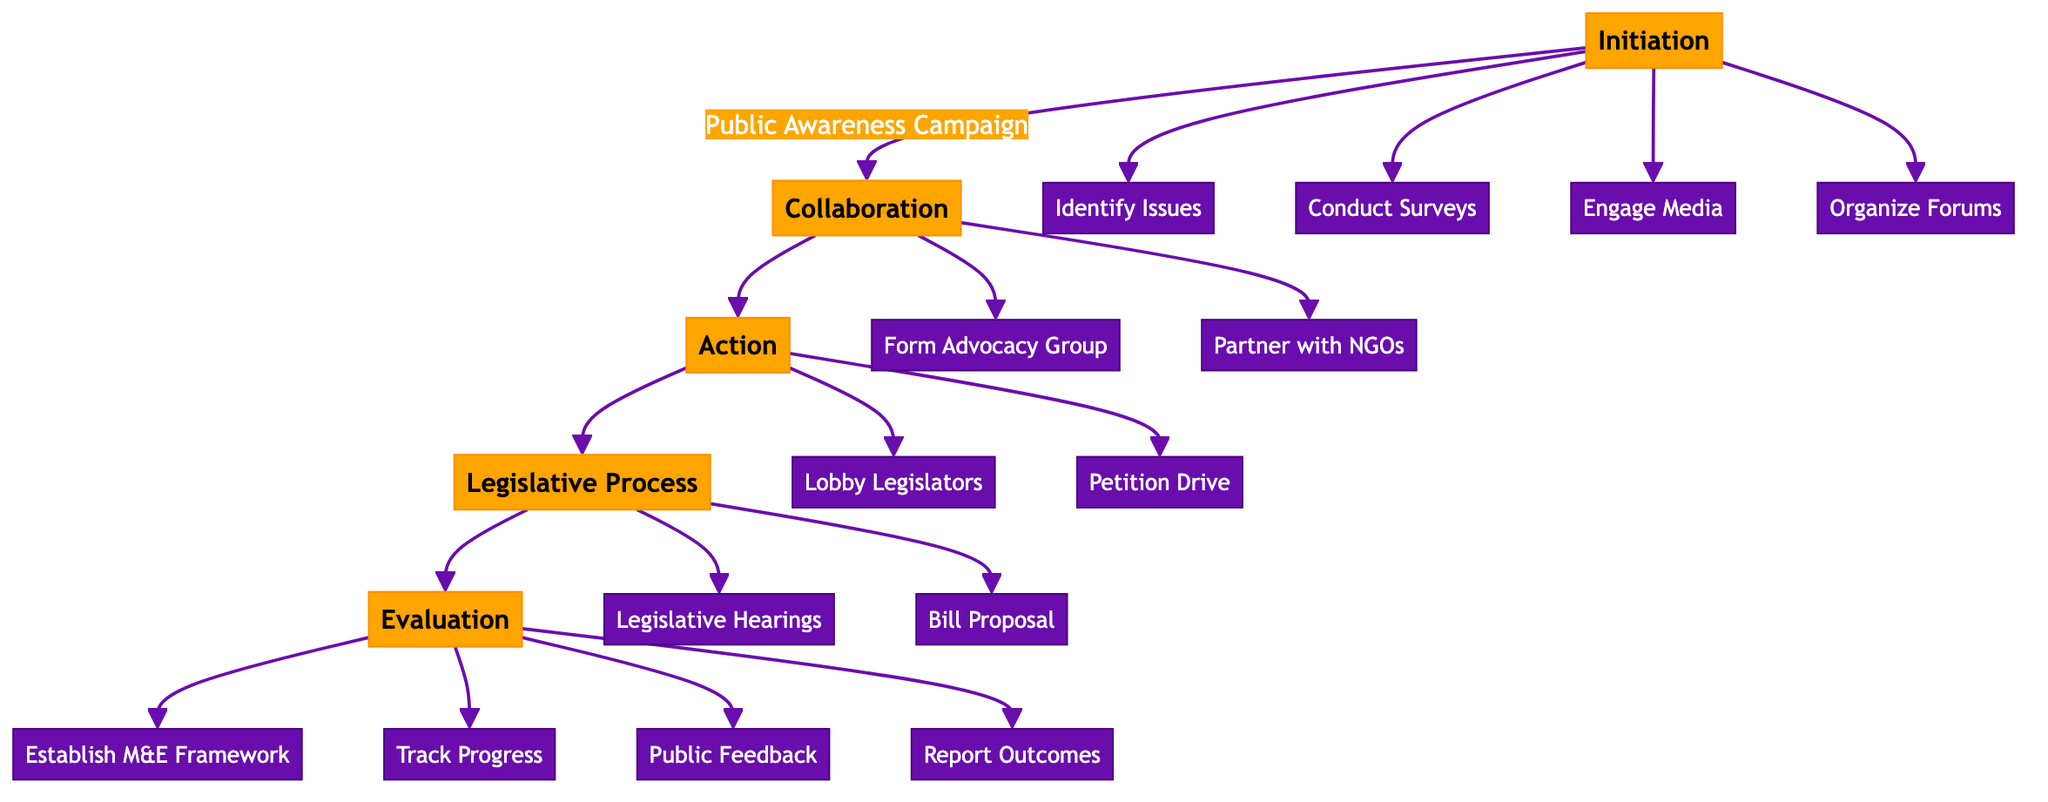What is the first step in the Public Awareness Campaign? The first step is clearly labeled as "Identify Key Constitutional Issues" under the Public Awareness Campaign section of the diagram.
Answer: Identify Key Constitutional Issues How many main phases are there in the pathway? By analyzing the flowchart, there are five main phases: Initiation, Collaboration, Action, Legislative Process, and Evaluation.
Answer: 5 What step follows "Prepare Lobbying Dossier" in the Lobbying section? The diagram indicates that "Schedule Meetings with Legislators" directly follows the "Prepare Lobbying Dossier" step in the Lobbying section.
Answer: Schedule Meetings with Legislators What are the last steps in the Evaluation phase? The last steps are "Report Outcomes to Stakeholders," as listed as the fourth step in the Evaluation phase of the diagram.
Answer: Report Outcomes to Stakeholders What type of partnership is formed in the Collaboration phase? The diagram shows that partnerships with NGOs are formed during the Collaboration phase, indicated in the PartnershipWithNGOs section.
Answer: Partnerships with NGOs How many steps are involved in the Legislative Hearings section? There are four steps involved in the Legislative Hearings section, as outlined in the diagram.
Answer: 4 What is the role of "Engage with Local Media" in the pathway? The step "Engage with Local Media" serves as the third step in the Public Awareness Campaign, contributing to increasing public awareness of constitutional issues.
Answer: Engaging with Local Media What follows "Draft Constitutional Amendment Bill" in the Legislative Process? The diagram shows that "Secure Parliamentary Sponsorship" follows "Draft Constitutional Amendment Bill" in the Bill Proposal section.
Answer: Secure Parliamentary Sponsorship What is the purpose of the Monitoring and Evaluation Framework? The purpose is to systematically track and assess the progress of constitutional reforms, as indicated in the Evaluation phase of the diagram.
Answer: Track and assess progress 